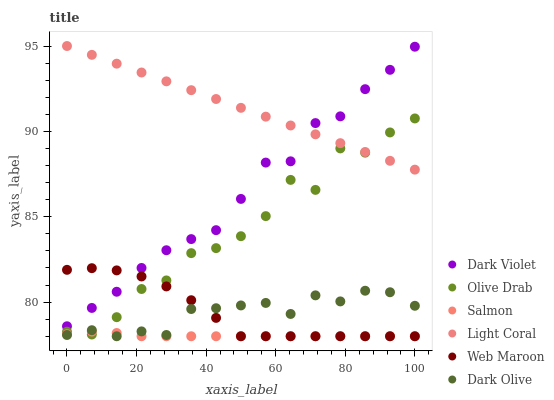Does Salmon have the minimum area under the curve?
Answer yes or no. Yes. Does Light Coral have the maximum area under the curve?
Answer yes or no. Yes. Does Dark Olive have the minimum area under the curve?
Answer yes or no. No. Does Dark Olive have the maximum area under the curve?
Answer yes or no. No. Is Light Coral the smoothest?
Answer yes or no. Yes. Is Olive Drab the roughest?
Answer yes or no. Yes. Is Dark Olive the smoothest?
Answer yes or no. No. Is Dark Olive the roughest?
Answer yes or no. No. Does Salmon have the lowest value?
Answer yes or no. Yes. Does Dark Violet have the lowest value?
Answer yes or no. No. Does Light Coral have the highest value?
Answer yes or no. Yes. Does Dark Olive have the highest value?
Answer yes or no. No. Is Salmon less than Light Coral?
Answer yes or no. Yes. Is Light Coral greater than Web Maroon?
Answer yes or no. Yes. Does Web Maroon intersect Olive Drab?
Answer yes or no. Yes. Is Web Maroon less than Olive Drab?
Answer yes or no. No. Is Web Maroon greater than Olive Drab?
Answer yes or no. No. Does Salmon intersect Light Coral?
Answer yes or no. No. 